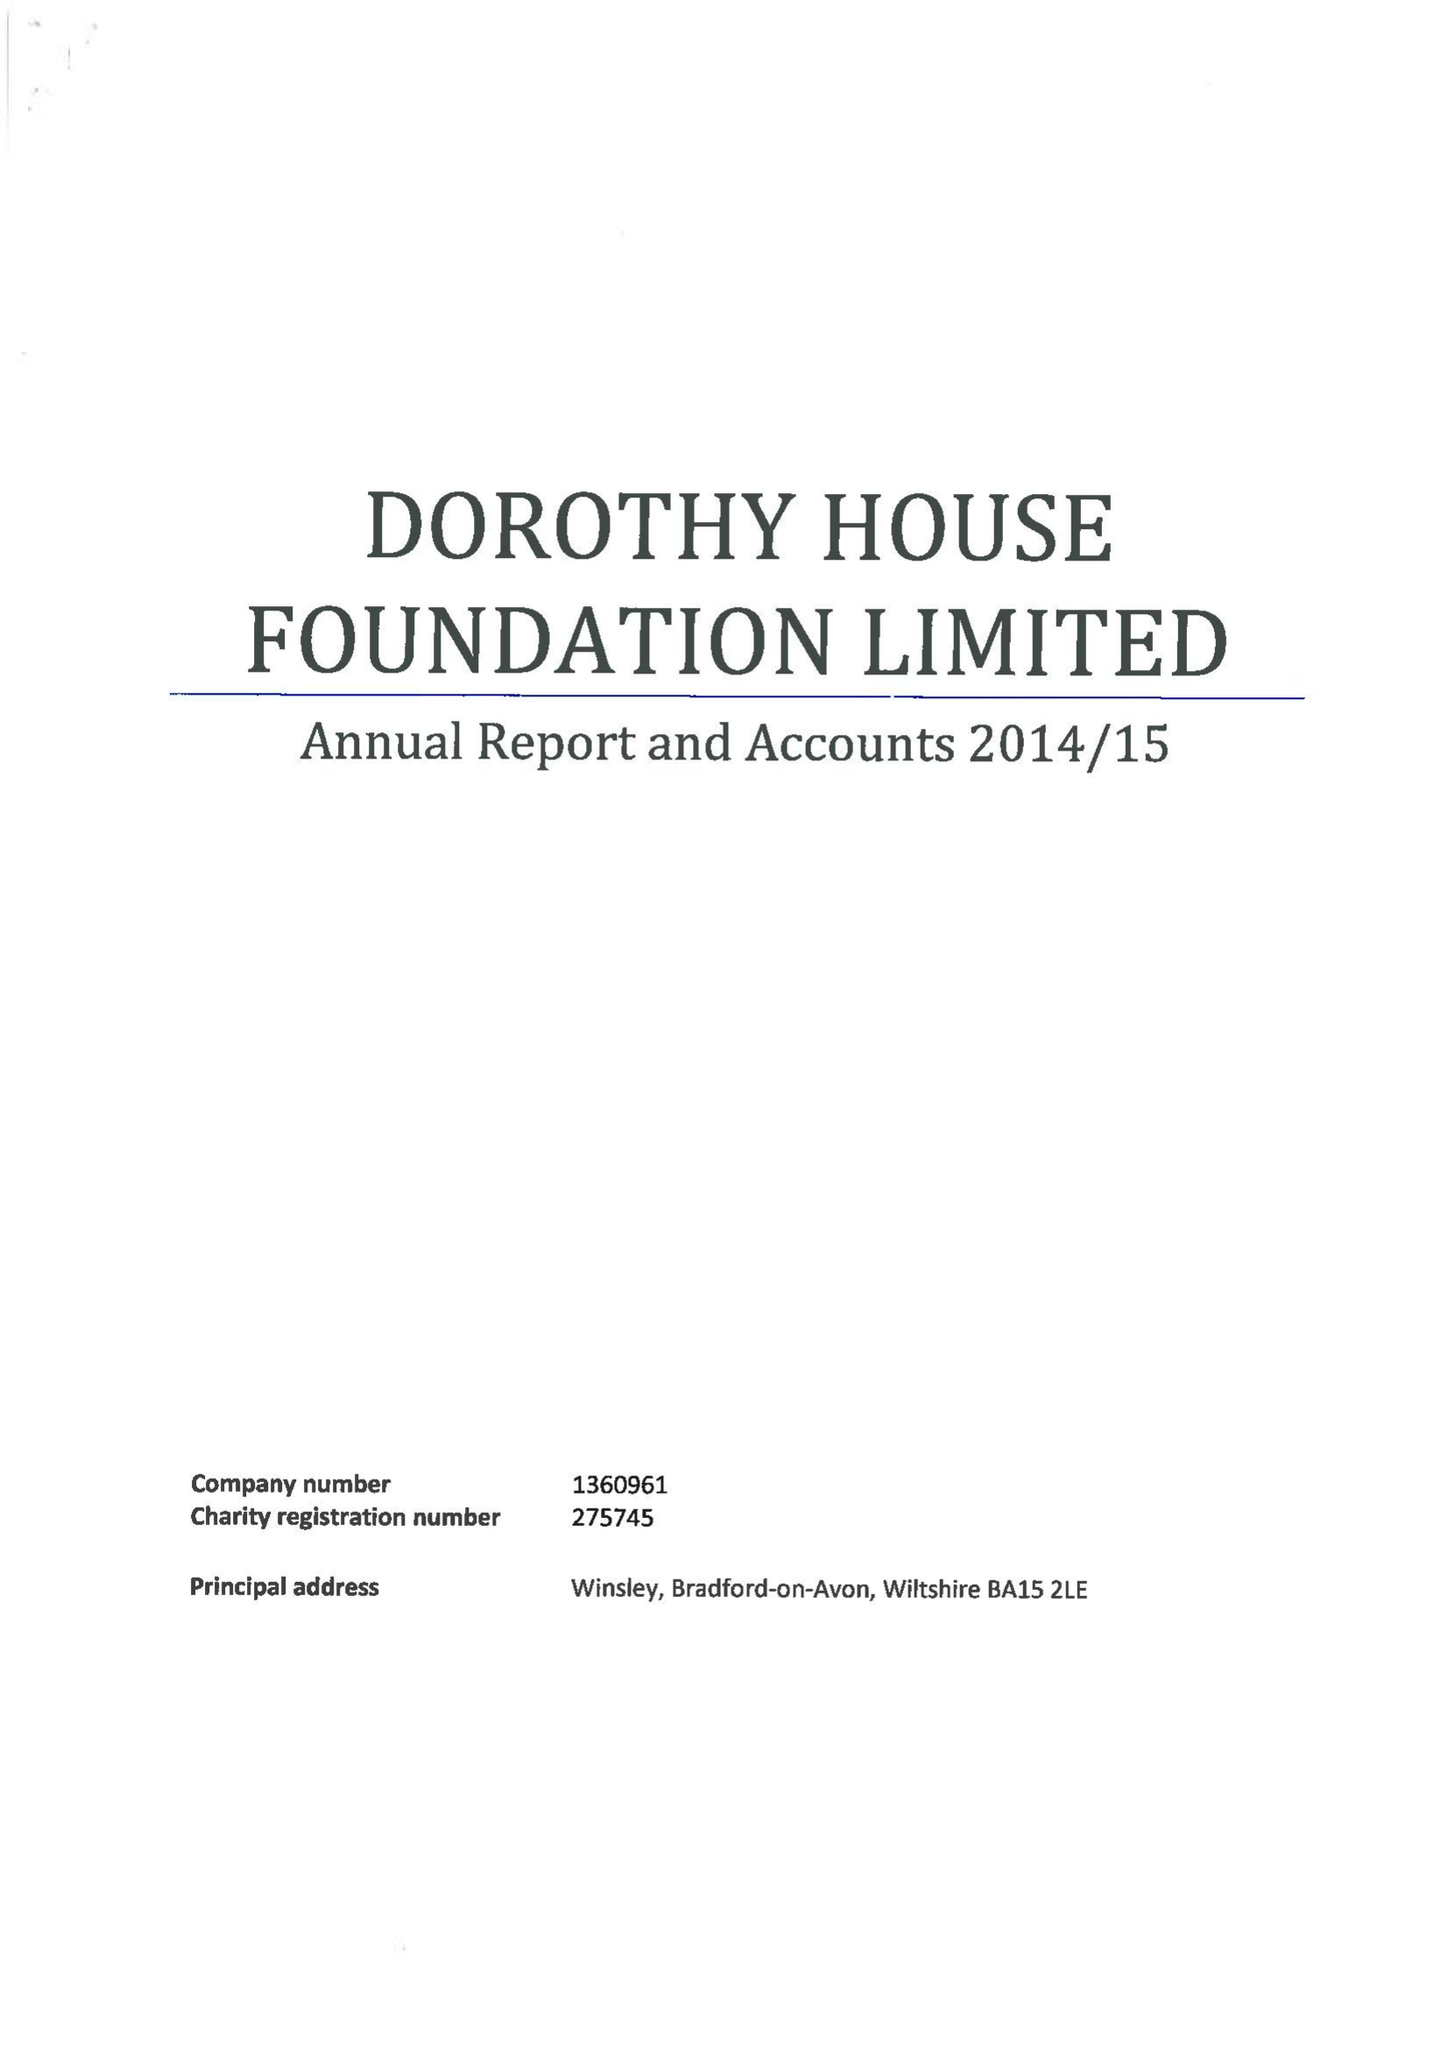What is the value for the address__post_town?
Answer the question using a single word or phrase. BRADFORD-ON-AVON 